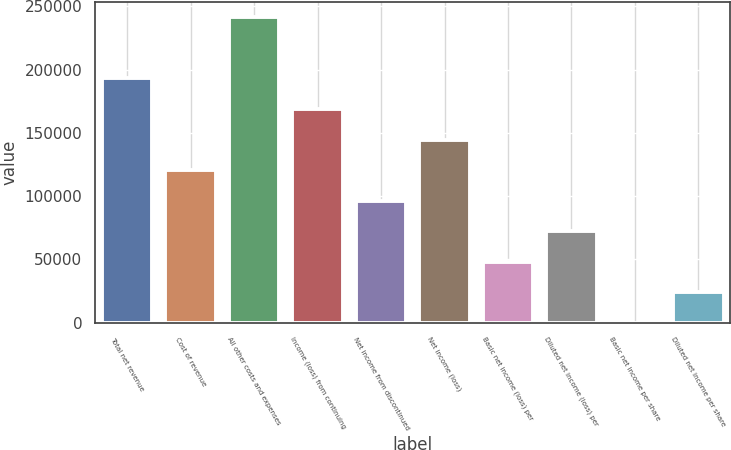<chart> <loc_0><loc_0><loc_500><loc_500><bar_chart><fcel>Total net revenue<fcel>Cost of revenue<fcel>All other costs and expenses<fcel>Income (loss) from continuing<fcel>Net income from discontinued<fcel>Net income (loss)<fcel>Basic net income (loss) per<fcel>Diluted net income (loss) per<fcel>Basic net income per share<fcel>Diluted net income per share<nl><fcel>192966<fcel>120604<fcel>241207<fcel>168845<fcel>96482.8<fcel>144724<fcel>48241.4<fcel>72362.1<fcel>0.04<fcel>24120.7<nl></chart> 